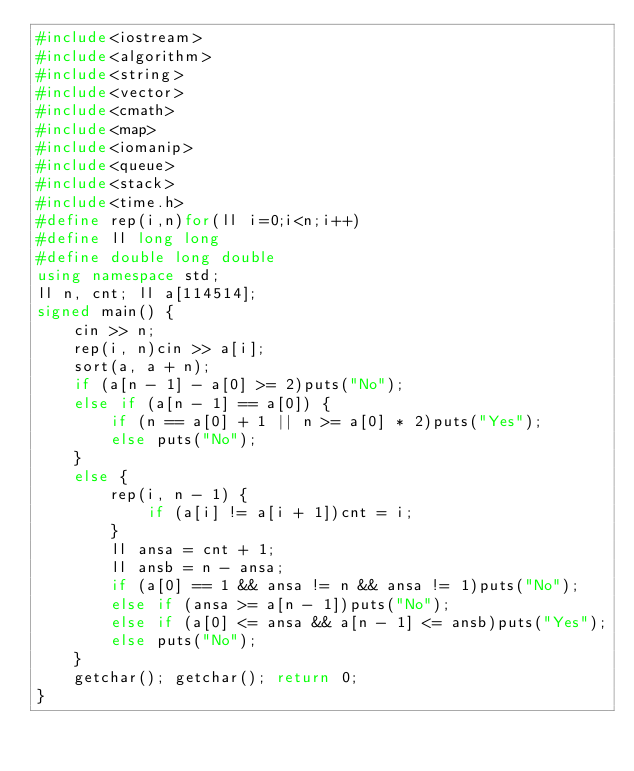<code> <loc_0><loc_0><loc_500><loc_500><_C++_>#include<iostream>
#include<algorithm>
#include<string>
#include<vector>
#include<cmath>
#include<map>
#include<iomanip>
#include<queue>
#include<stack>
#include<time.h>
#define rep(i,n)for(ll i=0;i<n;i++)
#define ll long long
#define double long double
using namespace std;
ll n, cnt; ll a[114514];
signed main() {
	cin >> n;
	rep(i, n)cin >> a[i];
	sort(a, a + n);
	if (a[n - 1] - a[0] >= 2)puts("No");
	else if (a[n - 1] == a[0]) {
		if (n == a[0] + 1 || n >= a[0] * 2)puts("Yes");
		else puts("No");
	}
	else {
		rep(i, n - 1) {
			if (a[i] != a[i + 1])cnt = i;
		}
		ll ansa = cnt + 1;
		ll ansb = n - ansa;
		if (a[0] == 1 && ansa != n && ansa != 1)puts("No");
		else if (ansa >= a[n - 1])puts("No");
		else if (a[0] <= ansa && a[n - 1] <= ansb)puts("Yes");
		else puts("No");
	}
	getchar(); getchar(); return 0;
}
</code> 